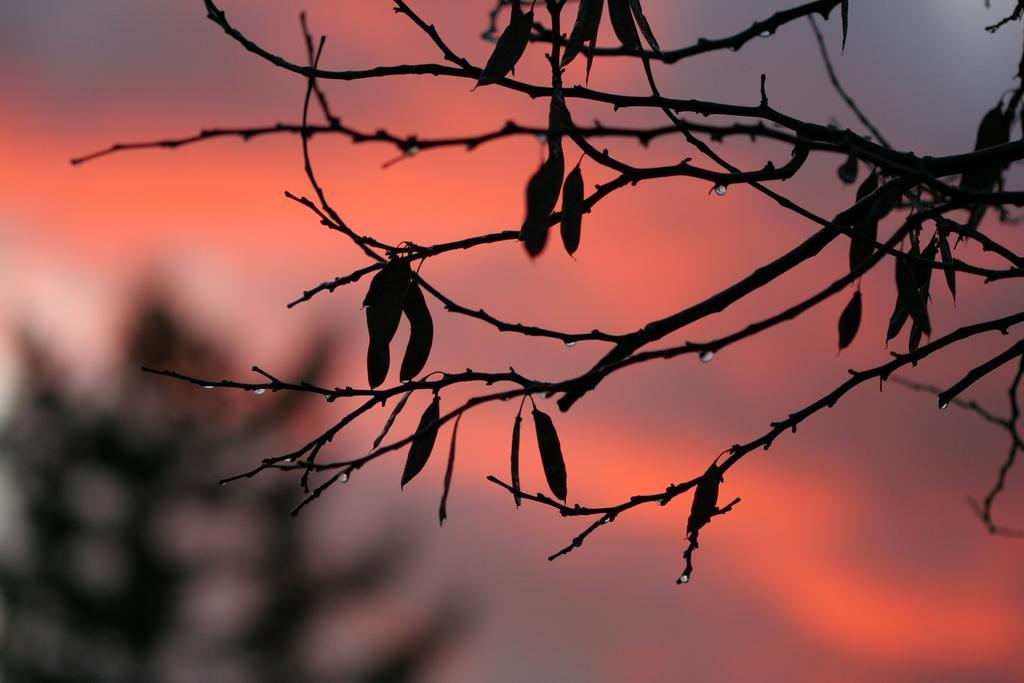Describe this image in one or two sentences. In this image we can see leaves on group of branches of a tree. 